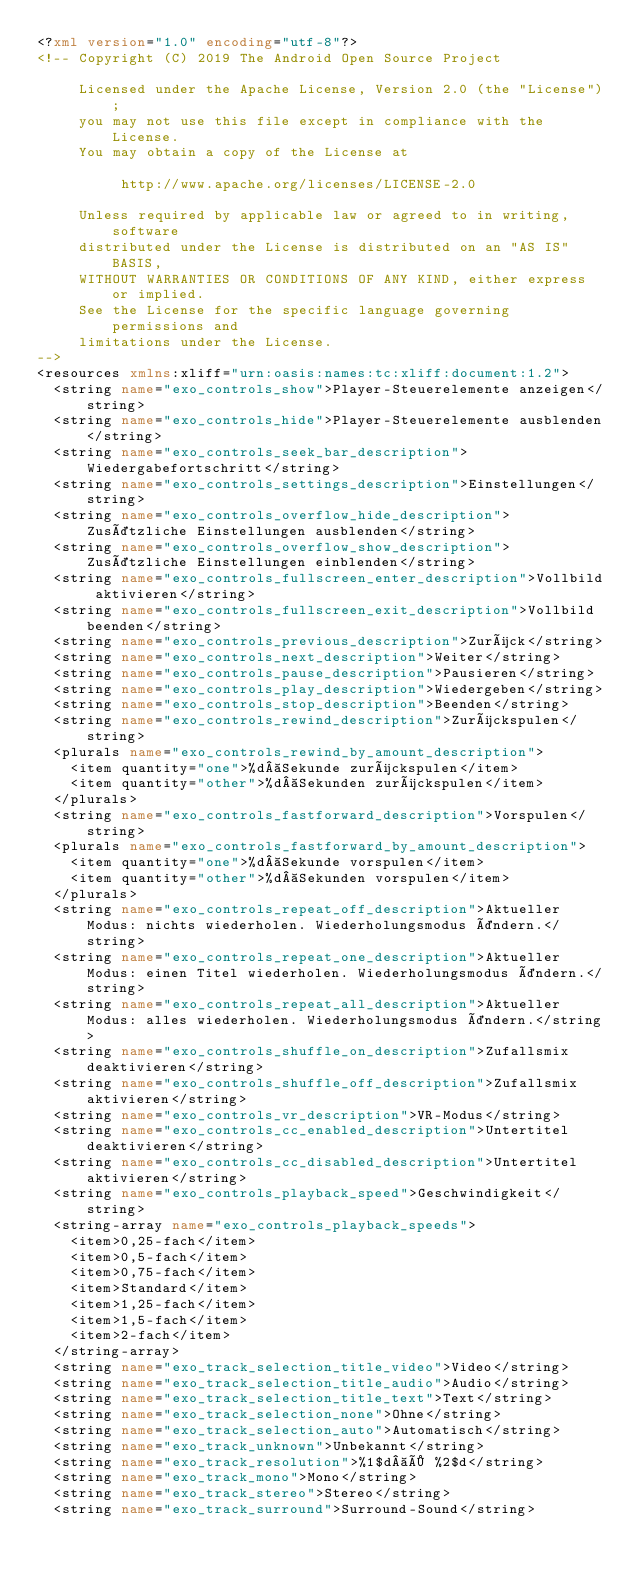<code> <loc_0><loc_0><loc_500><loc_500><_XML_><?xml version="1.0" encoding="utf-8"?>
<!-- Copyright (C) 2019 The Android Open Source Project

     Licensed under the Apache License, Version 2.0 (the "License");
     you may not use this file except in compliance with the License.
     You may obtain a copy of the License at

          http://www.apache.org/licenses/LICENSE-2.0

     Unless required by applicable law or agreed to in writing, software
     distributed under the License is distributed on an "AS IS" BASIS,
     WITHOUT WARRANTIES OR CONDITIONS OF ANY KIND, either express or implied.
     See the License for the specific language governing permissions and
     limitations under the License.
-->
<resources xmlns:xliff="urn:oasis:names:tc:xliff:document:1.2">
  <string name="exo_controls_show">Player-Steuerelemente anzeigen</string>
  <string name="exo_controls_hide">Player-Steuerelemente ausblenden</string>
  <string name="exo_controls_seek_bar_description">Wiedergabefortschritt</string>
  <string name="exo_controls_settings_description">Einstellungen</string>
  <string name="exo_controls_overflow_hide_description">Zusätzliche Einstellungen ausblenden</string>
  <string name="exo_controls_overflow_show_description">Zusätzliche Einstellungen einblenden</string>
  <string name="exo_controls_fullscreen_enter_description">Vollbild aktivieren</string>
  <string name="exo_controls_fullscreen_exit_description">Vollbild beenden</string>
  <string name="exo_controls_previous_description">Zurück</string>
  <string name="exo_controls_next_description">Weiter</string>
  <string name="exo_controls_pause_description">Pausieren</string>
  <string name="exo_controls_play_description">Wiedergeben</string>
  <string name="exo_controls_stop_description">Beenden</string>
  <string name="exo_controls_rewind_description">Zurückspulen</string>
  <plurals name="exo_controls_rewind_by_amount_description">
    <item quantity="one">%d Sekunde zurückspulen</item>
    <item quantity="other">%d Sekunden zurückspulen</item>
  </plurals>
  <string name="exo_controls_fastforward_description">Vorspulen</string>
  <plurals name="exo_controls_fastforward_by_amount_description">
    <item quantity="one">%d Sekunde vorspulen</item>
    <item quantity="other">%d Sekunden vorspulen</item>
  </plurals>
  <string name="exo_controls_repeat_off_description">Aktueller Modus: nichts wiederholen. Wiederholungsmodus ändern.</string>
  <string name="exo_controls_repeat_one_description">Aktueller Modus: einen Titel wiederholen. Wiederholungsmodus ändern.</string>
  <string name="exo_controls_repeat_all_description">Aktueller Modus: alles wiederholen. Wiederholungsmodus ändern.</string>
  <string name="exo_controls_shuffle_on_description">Zufallsmix deaktivieren</string>
  <string name="exo_controls_shuffle_off_description">Zufallsmix aktivieren</string>
  <string name="exo_controls_vr_description">VR-Modus</string>
  <string name="exo_controls_cc_enabled_description">Untertitel deaktivieren</string>
  <string name="exo_controls_cc_disabled_description">Untertitel aktivieren</string>
  <string name="exo_controls_playback_speed">Geschwindigkeit</string>
  <string-array name="exo_controls_playback_speeds">
    <item>0,25-fach</item>
    <item>0,5-fach</item>
    <item>0,75-fach</item>
    <item>Standard</item>
    <item>1,25-fach</item>
    <item>1,5-fach</item>
    <item>2-fach</item>
  </string-array>
  <string name="exo_track_selection_title_video">Video</string>
  <string name="exo_track_selection_title_audio">Audio</string>
  <string name="exo_track_selection_title_text">Text</string>
  <string name="exo_track_selection_none">Ohne</string>
  <string name="exo_track_selection_auto">Automatisch</string>
  <string name="exo_track_unknown">Unbekannt</string>
  <string name="exo_track_resolution">%1$d × %2$d</string>
  <string name="exo_track_mono">Mono</string>
  <string name="exo_track_stereo">Stereo</string>
  <string name="exo_track_surround">Surround-Sound</string></code> 